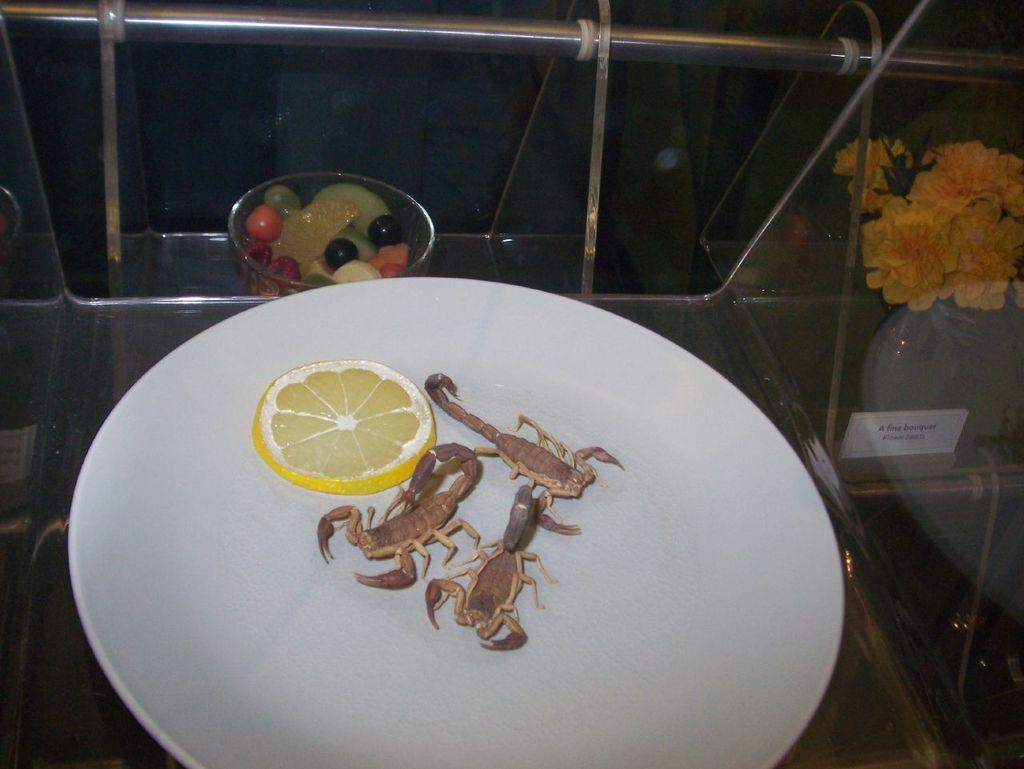What is present on the plate in the image? There is no information about what is on the plate in the image. What is in the bowl that is visible in the image? There is a bowl in the image, but the contents are not specified. What type of food can be seen in the image? There are fruits and crabs visible in the image. What is the glass used for in the image? The purpose of the glass in the image is not specified. What decorative elements are present in the image? There are flowers visible in the image. What type of beam is holding up the ground in the image? There is no beam or ground present in the image. What kind of humor can be seen in the image? There is no humor depicted in the image. 